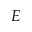Convert formula to latex. <formula><loc_0><loc_0><loc_500><loc_500>E</formula> 